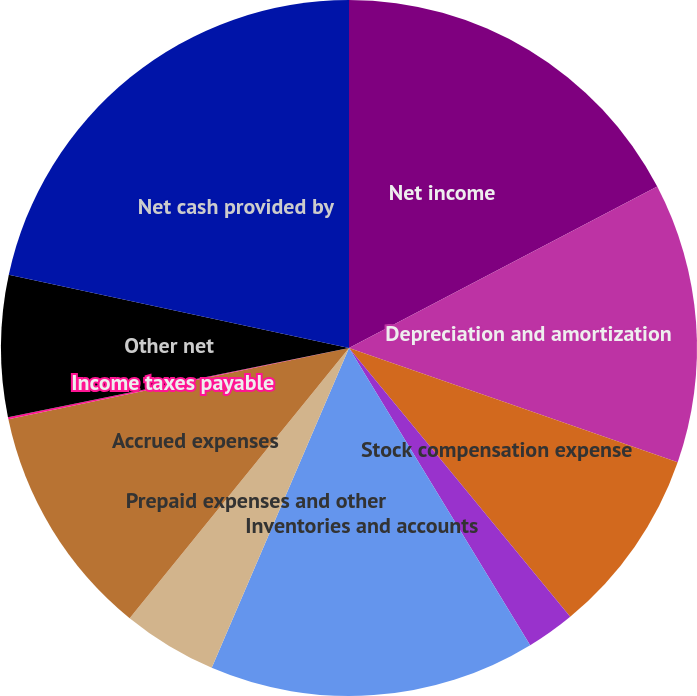<chart> <loc_0><loc_0><loc_500><loc_500><pie_chart><fcel>Net income<fcel>Depreciation and amortization<fcel>Stock compensation expense<fcel>Deferred income taxes<fcel>Inventories and accounts<fcel>Prepaid expenses and other<fcel>Accrued expenses<fcel>Income taxes payable<fcel>Other net<fcel>Net cash provided by<nl><fcel>17.32%<fcel>13.01%<fcel>8.71%<fcel>2.25%<fcel>15.17%<fcel>4.4%<fcel>10.86%<fcel>0.1%<fcel>6.56%<fcel>21.63%<nl></chart> 